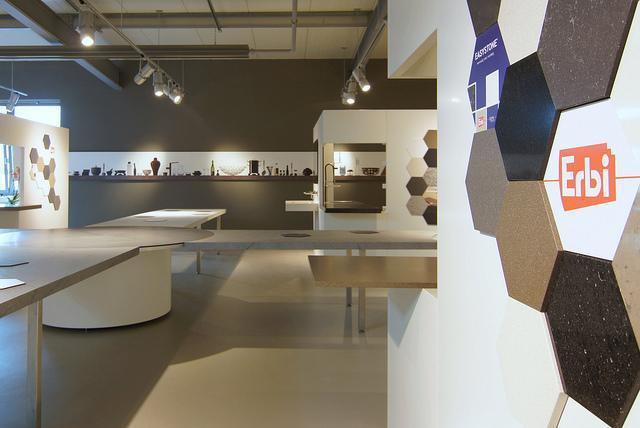How many cakes are on top of the cake caddy?
Give a very brief answer. 0. 